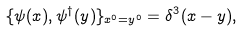Convert formula to latex. <formula><loc_0><loc_0><loc_500><loc_500>\{ \psi ( x ) , \psi ^ { \dagger } ( y ) \} _ { x ^ { 0 } = y ^ { 0 } } = \delta ^ { 3 } ( { x } - { y } ) ,</formula> 